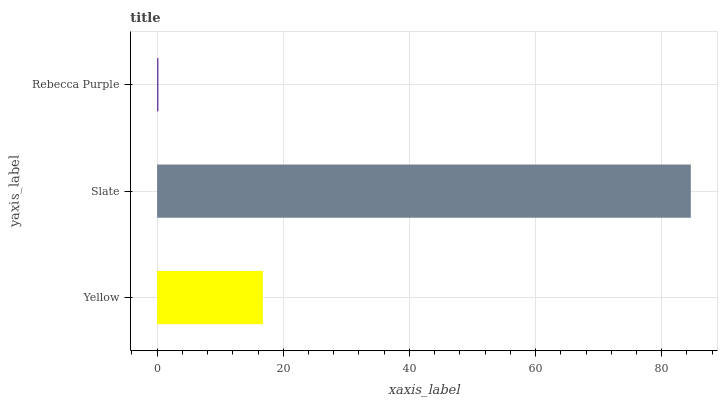Is Rebecca Purple the minimum?
Answer yes or no. Yes. Is Slate the maximum?
Answer yes or no. Yes. Is Slate the minimum?
Answer yes or no. No. Is Rebecca Purple the maximum?
Answer yes or no. No. Is Slate greater than Rebecca Purple?
Answer yes or no. Yes. Is Rebecca Purple less than Slate?
Answer yes or no. Yes. Is Rebecca Purple greater than Slate?
Answer yes or no. No. Is Slate less than Rebecca Purple?
Answer yes or no. No. Is Yellow the high median?
Answer yes or no. Yes. Is Yellow the low median?
Answer yes or no. Yes. Is Rebecca Purple the high median?
Answer yes or no. No. Is Slate the low median?
Answer yes or no. No. 